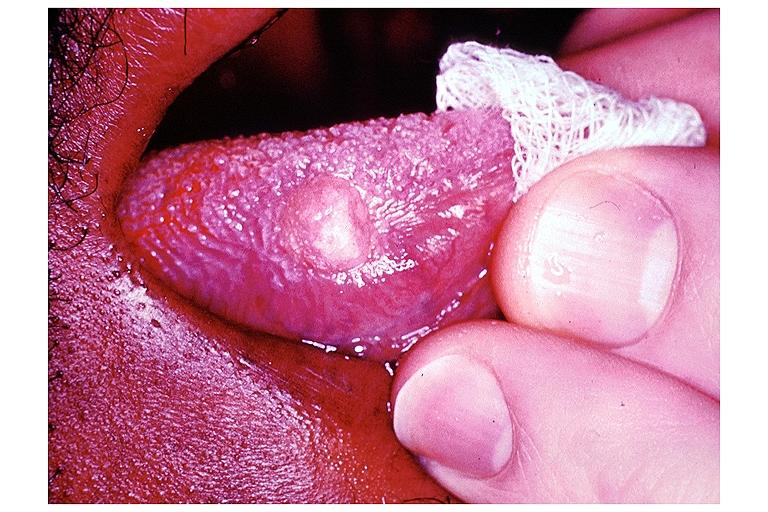does this image shows of smooth muscle cell with lipid in sarcoplasm and lipid show granular cell tumor?
Answer the question using a single word or phrase. No 